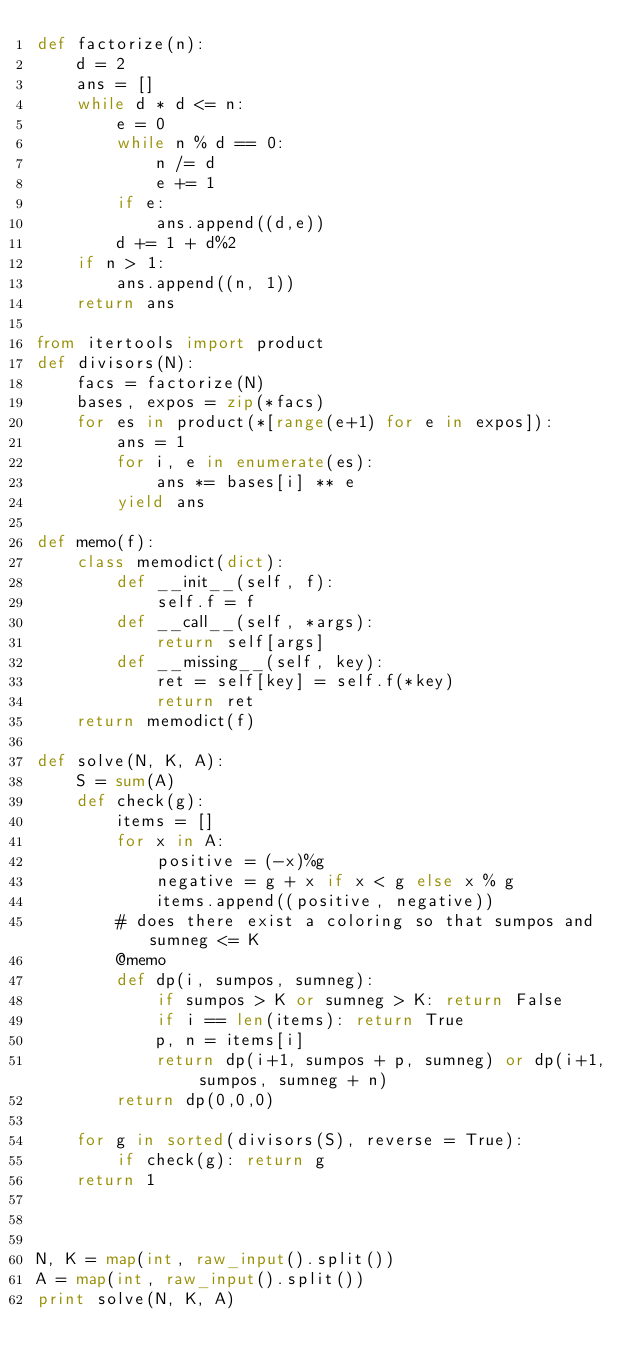<code> <loc_0><loc_0><loc_500><loc_500><_Python_>def factorize(n):
    d = 2
    ans = []
    while d * d <= n:
        e = 0
        while n % d == 0:
            n /= d
            e += 1
        if e:
            ans.append((d,e))
        d += 1 + d%2
    if n > 1:
        ans.append((n, 1))
    return ans

from itertools import product
def divisors(N):
    facs = factorize(N)
    bases, expos = zip(*facs)
    for es in product(*[range(e+1) for e in expos]):
        ans = 1
        for i, e in enumerate(es):
            ans *= bases[i] ** e
        yield ans

def memo(f):
    class memodict(dict):
        def __init__(self, f):
            self.f = f
        def __call__(self, *args):
            return self[args]
        def __missing__(self, key):
            ret = self[key] = self.f(*key)
            return ret
    return memodict(f)

def solve(N, K, A):
    S = sum(A)
    def check(g):
        items = []
        for x in A:
            positive = (-x)%g
            negative = g + x if x < g else x % g
            items.append((positive, negative))
        # does there exist a coloring so that sumpos and sumneg <= K
        @memo
        def dp(i, sumpos, sumneg):
            if sumpos > K or sumneg > K: return False
            if i == len(items): return True
            p, n = items[i]
            return dp(i+1, sumpos + p, sumneg) or dp(i+1, sumpos, sumneg + n)
        return dp(0,0,0)
    
    for g in sorted(divisors(S), reverse = True):
        if check(g): return g
    return 1
        


N, K = map(int, raw_input().split())
A = map(int, raw_input().split())
print solve(N, K, A)
</code> 